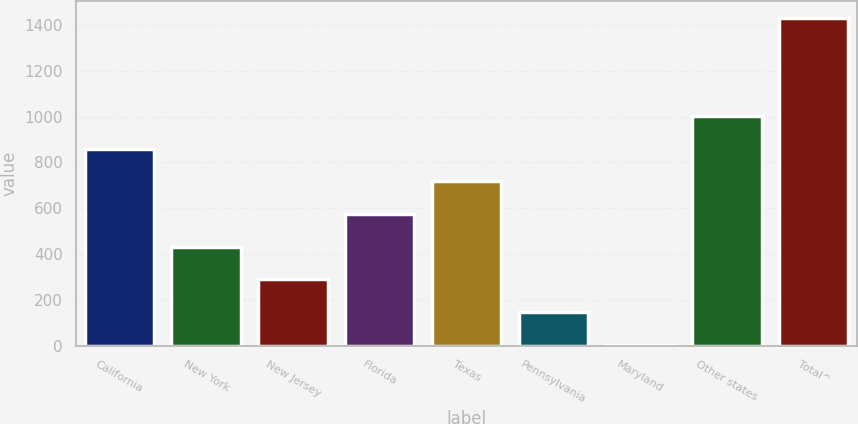Convert chart. <chart><loc_0><loc_0><loc_500><loc_500><bar_chart><fcel>California<fcel>New York<fcel>New Jersey<fcel>Florida<fcel>Texas<fcel>Pennsylvania<fcel>Maryland<fcel>Other states<fcel>Total^<nl><fcel>860.2<fcel>432.1<fcel>289.4<fcel>574.8<fcel>717.5<fcel>146.7<fcel>4<fcel>1002.9<fcel>1431<nl></chart> 